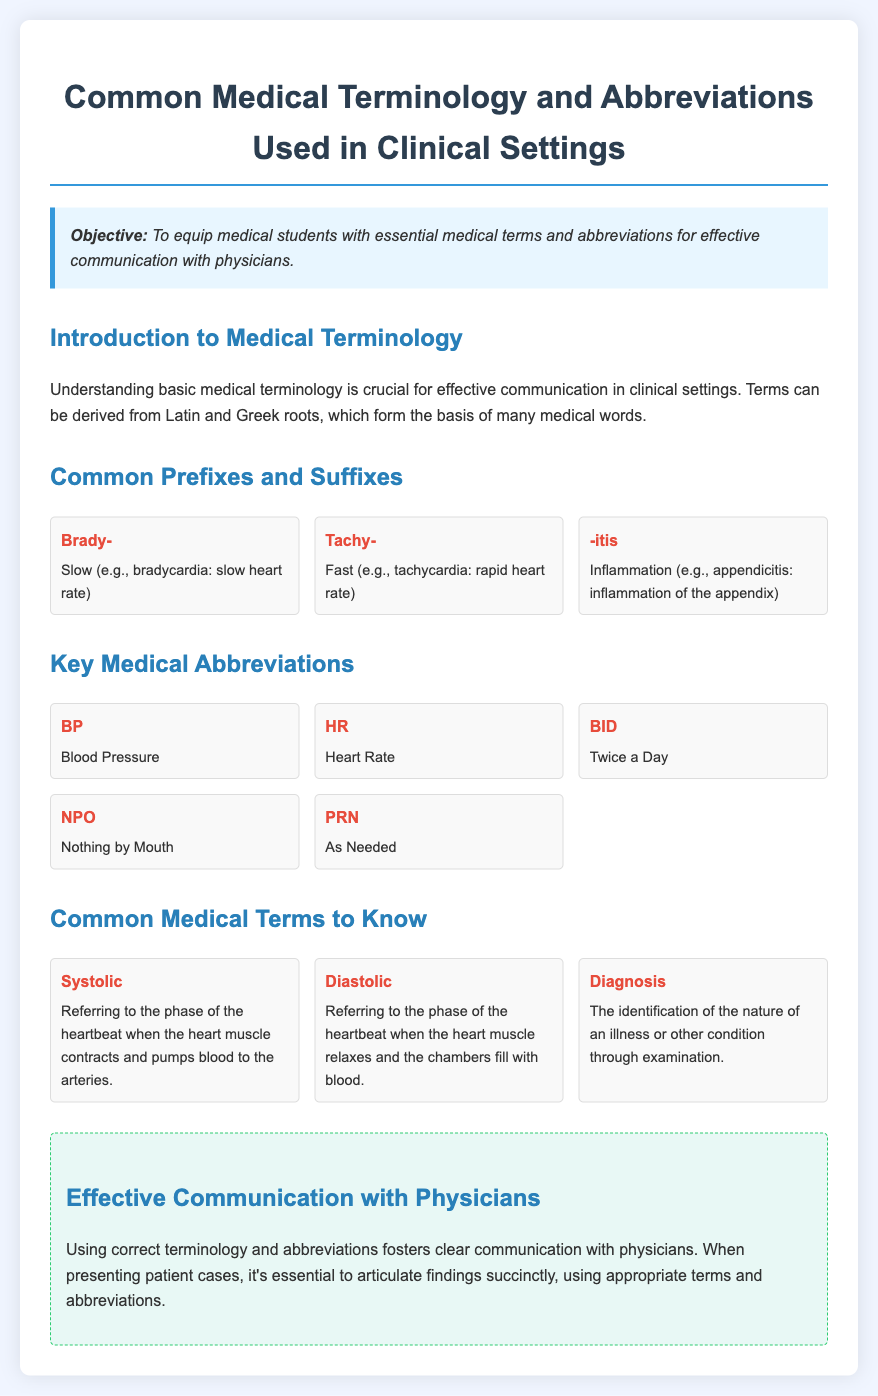What is the objective of the document? The objective is to equip medical students with essential medical terms and abbreviations for effective communication with physicians.
Answer: To equip medical students with essential medical terms and abbreviations for effective communication with physicians What does "HR" stand for? "HR" is a medical abbreviation found in the document that refers to heart rate.
Answer: Heart Rate What is the meaning of "NPO"? "NPO" is an abbreviation used in the clinical setting; it means nothing by mouth.
Answer: Nothing by Mouth What is the definition of "Systolic"? The document defines systolic as referring to the phase of the heartbeat when the heart muscle contracts and pumps blood to the arteries.
Answer: Referring to the phase of the heartbeat when the heart muscle contracts and pumps blood to the arteries What are the common prefixes listed in the document? The document includes common prefixes like "Brady-" and "Tachy-".
Answer: Brady- and Tachy- Which term means inflammation? The term associated with inflammation in the document is "-itis".
Answer: -itis What tip is provided for effective communication with physicians? The document suggests that using correct terminology and abbreviations fosters clear communication with physicians.
Answer: Using correct terminology and abbreviations fosters clear communication with physicians How many key medical abbreviations are listed in the document? The document lists five key medical abbreviations.
Answer: Five What is the term for the phase when the heart muscle relaxes? The term used in the document for this phase is "Diastolic".
Answer: Diastolic 